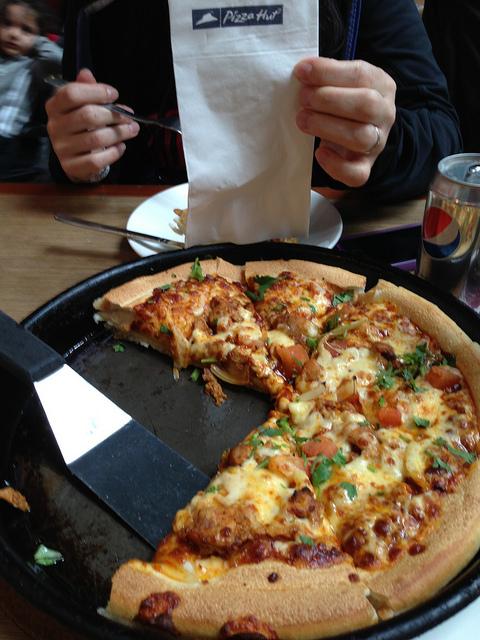What restaurant is this napkin from?
Write a very short answer. Pizza hut. What words can you read?
Keep it brief. Pizza hut. What toppings are on the pizza?
Quick response, please. Basil. How many pieces of pizza have already been eaten?
Concise answer only. 2. 